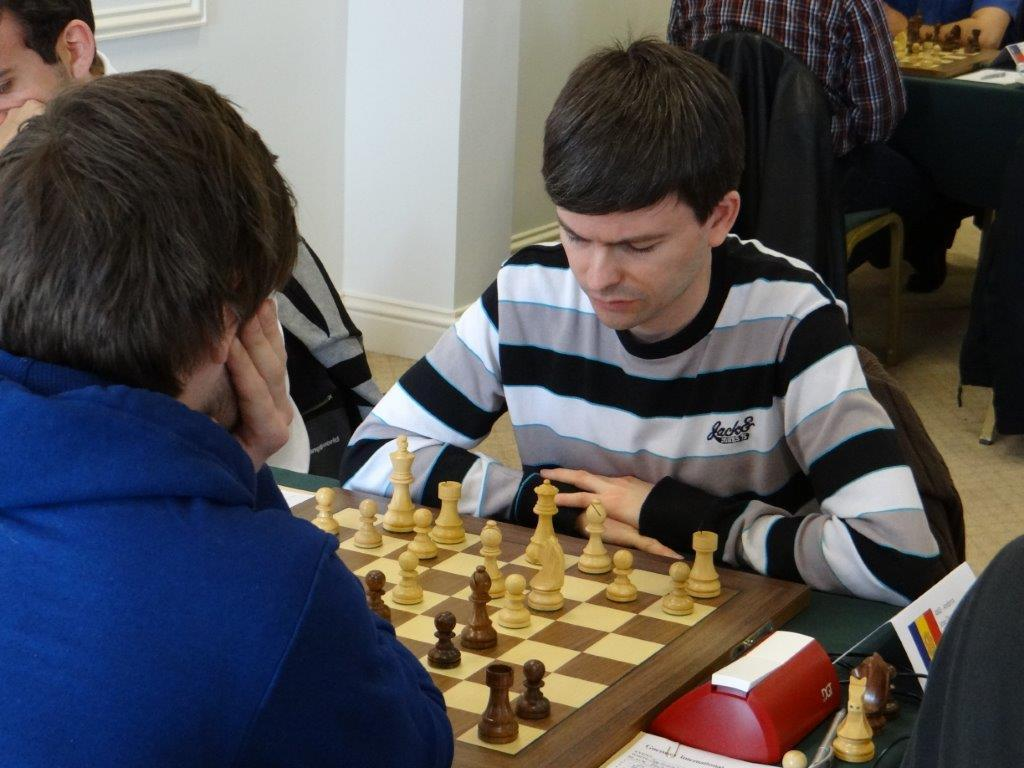What are the people in the image doing? There is a group of people sitting in the image, and they are likely playing a game or engaging in a discussion. What game might they be playing, based on the objects in the image? There is a chess board in front of the group, so they might be playing chess. Are there any other objects visible in the image? Yes, there are coins visible in the image. What is the color of the wall in the background? The wall in the background is white. What type of boot is being worn by the person on the left side of the image? There is no person wearing a boot in the image; the focus is on the group of people sitting and the chess board. 